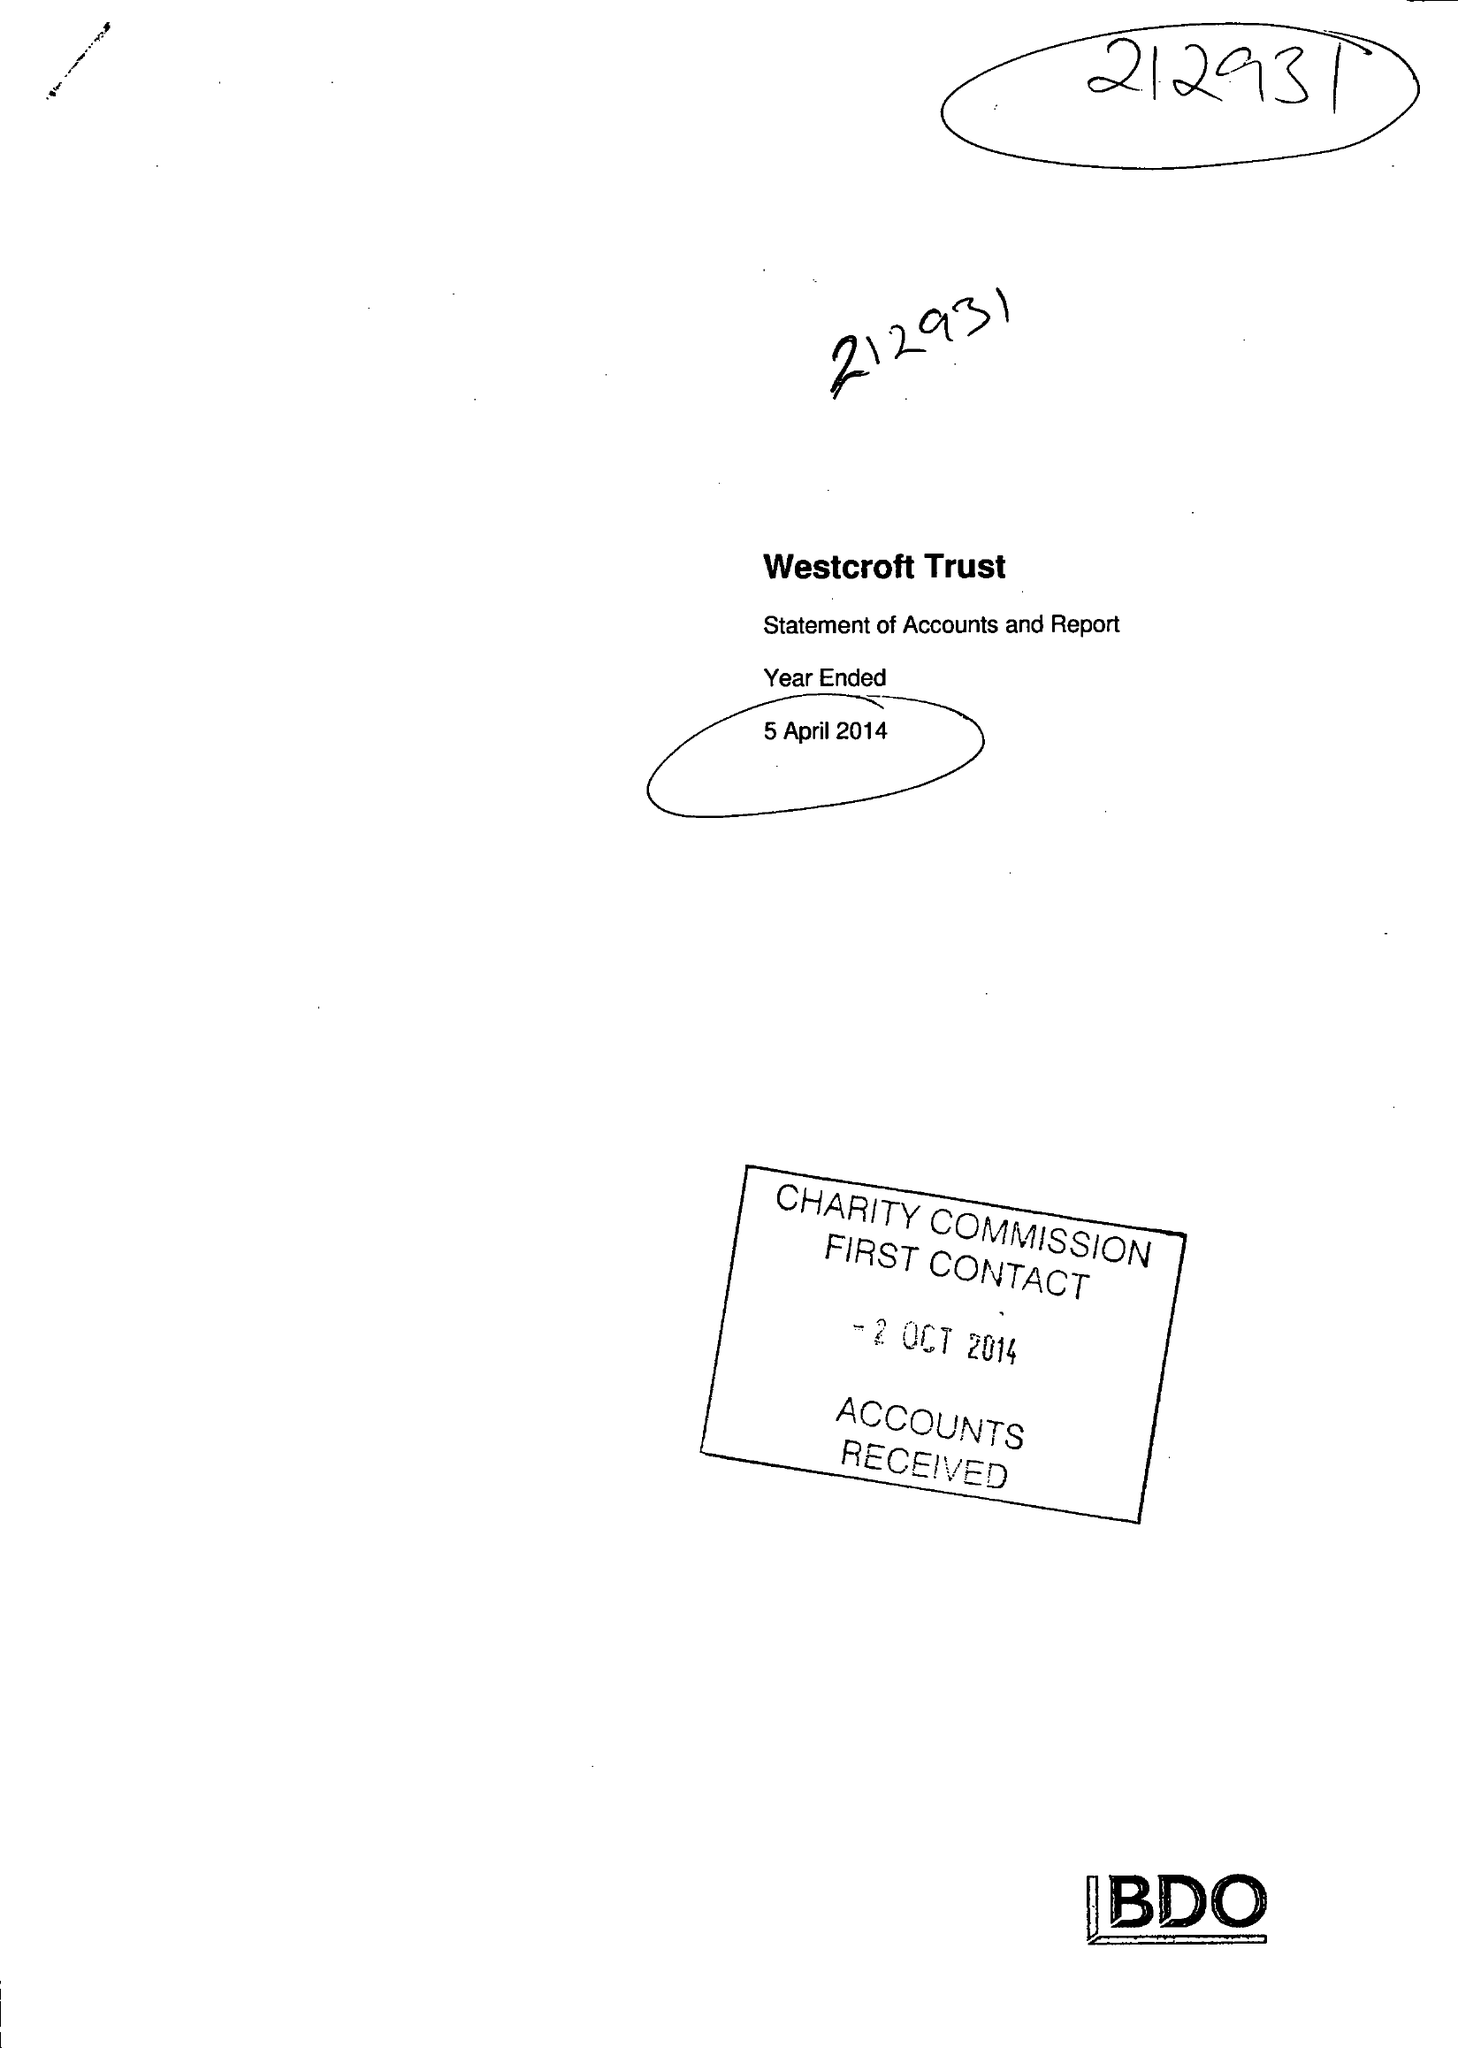What is the value for the charity_number?
Answer the question using a single word or phrase. 212931 